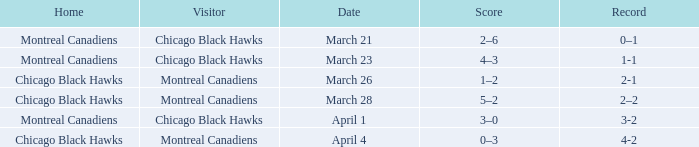What is the score for the team with a record of 2-1? 1–2. 